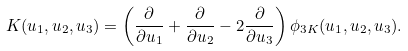Convert formula to latex. <formula><loc_0><loc_0><loc_500><loc_500>K ( u _ { 1 } , u _ { 2 } , u _ { 3 } ) = \left ( \frac { \partial } { \partial u _ { 1 } } + \frac { \partial } { \partial u _ { 2 } } - 2 \frac { \partial } { \partial u _ { 3 } } \right ) \phi _ { 3 K } ( u _ { 1 } , u _ { 2 } , u _ { 3 } ) .</formula> 